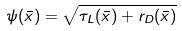<formula> <loc_0><loc_0><loc_500><loc_500>\psi ( \bar { x } ) = \sqrt { \tau _ { L } ( \bar { x } ) + r _ { D } ( \bar { x } ) }</formula> 